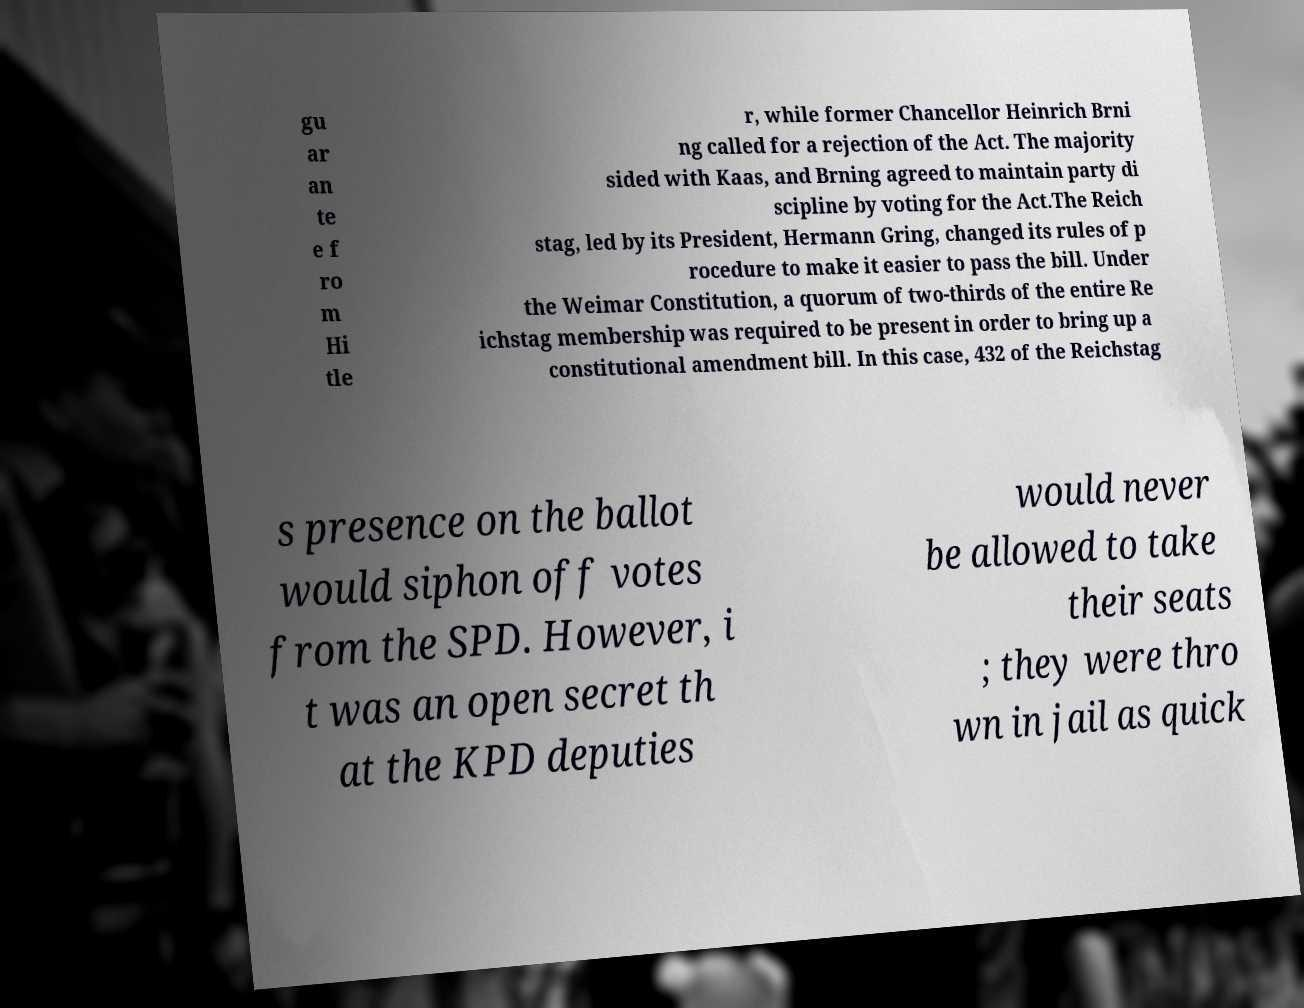For documentation purposes, I need the text within this image transcribed. Could you provide that? gu ar an te e f ro m Hi tle r, while former Chancellor Heinrich Brni ng called for a rejection of the Act. The majority sided with Kaas, and Brning agreed to maintain party di scipline by voting for the Act.The Reich stag, led by its President, Hermann Gring, changed its rules of p rocedure to make it easier to pass the bill. Under the Weimar Constitution, a quorum of two-thirds of the entire Re ichstag membership was required to be present in order to bring up a constitutional amendment bill. In this case, 432 of the Reichstag s presence on the ballot would siphon off votes from the SPD. However, i t was an open secret th at the KPD deputies would never be allowed to take their seats ; they were thro wn in jail as quick 